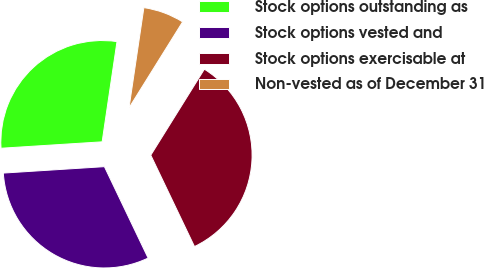Convert chart. <chart><loc_0><loc_0><loc_500><loc_500><pie_chart><fcel>Stock options outstanding as<fcel>Stock options vested and<fcel>Stock options exercisable at<fcel>Non-vested as of December 31<nl><fcel>28.35%<fcel>31.09%<fcel>34.03%<fcel>6.53%<nl></chart> 